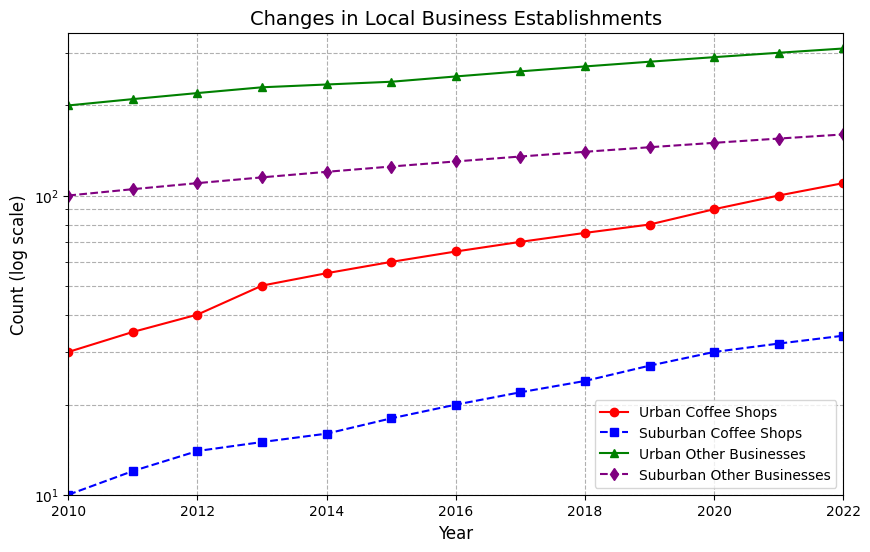How many coffee shops were in urban areas in 2018? Look for the data point corresponding to urban coffee shops in 2018 and note the count.
Answer: 75 By how much did the number of suburban coffee shops increase between 2010 and 2020? Subtract the count in 2010 from the count in 2020 for suburban coffee shops (30 - 10).
Answer: 20 Which type of business (coffee shops or other businesses) had more establishments in suburban areas in 2015? Compare the counts for suburban coffee shops (18) and suburban other businesses (125) in 2015.
Answer: Other businesses How many urban businesses in total were there in 2020 if you sum coffee shops and other businesses? Add the counts of urban coffee shops (90) and other urban businesses (290) in 2020 (90 + 290).
Answer: 380 What is the difference in the number of urban coffee shops between 2012 and 2022? Subtract the count in 2012 from the count in 2022 for urban coffee shops (110 - 40).
Answer: 70 In which year did suburban other businesses reach 150 establishments? Locate the year when the count for suburban other businesses first hits 150. It’s clear by looking at the trend.
Answer: 2020 How does the growth trend of suburban coffee shops compare to that of urban coffee shops? Compare the slopes of the lines representing suburban coffee shops and urban coffee shops. The suburban coffee shops’ line is less steep showing slower growth.
Answer: Slower growth Which year shows the smallest gap between the number of coffee shops in urban and suburban areas? Observe the plot and compare the differences between urban and suburban coffee shops for each year; 2011 shows a smaller gap due to closer point positions.
Answer: 2011 What visual element represents other businesses in suburban areas? Identify the visual coloring and marker style by looking at the legend: Suburban other businesses are purple with diamond markers.
Answer: Purple with diamonds What was the count trend for suburban other businesses from 2010 to 2022? Observe the line representing suburban other businesses and describe its trend. It shows a steady, linear increase.
Answer: Steady increase 